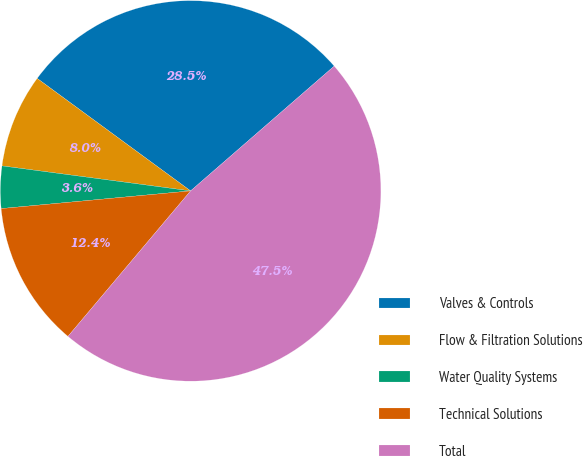Convert chart. <chart><loc_0><loc_0><loc_500><loc_500><pie_chart><fcel>Valves & Controls<fcel>Flow & Filtration Solutions<fcel>Water Quality Systems<fcel>Technical Solutions<fcel>Total<nl><fcel>28.54%<fcel>7.97%<fcel>3.58%<fcel>12.37%<fcel>47.53%<nl></chart> 